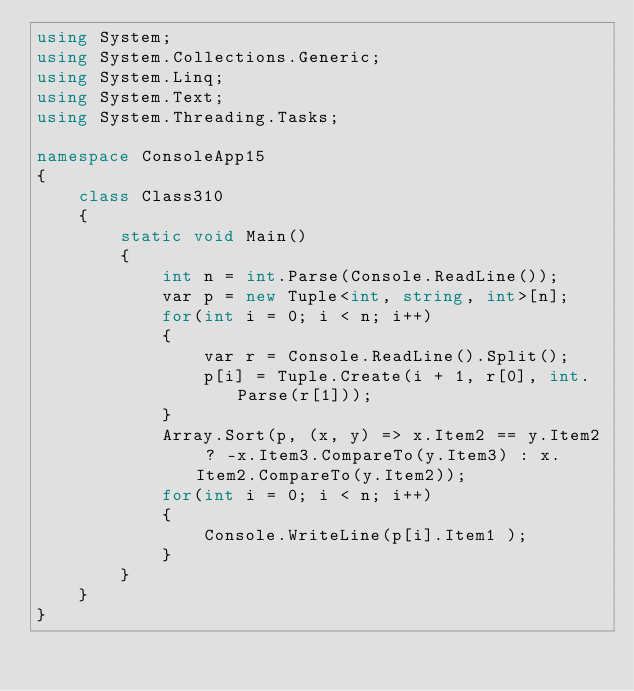<code> <loc_0><loc_0><loc_500><loc_500><_C#_>using System;
using System.Collections.Generic;
using System.Linq;
using System.Text;
using System.Threading.Tasks;

namespace ConsoleApp15
{
    class Class310
    {
        static void Main()
        {
            int n = int.Parse(Console.ReadLine());
            var p = new Tuple<int, string, int>[n];
            for(int i = 0; i < n; i++)
            {
                var r = Console.ReadLine().Split();
                p[i] = Tuple.Create(i + 1, r[0], int.Parse(r[1]));
            }
            Array.Sort(p, (x, y) => x.Item2 == y.Item2 ? -x.Item3.CompareTo(y.Item3) : x.Item2.CompareTo(y.Item2));
            for(int i = 0; i < n; i++)
            {
                Console.WriteLine(p[i].Item1 );
            }
        }
    }
}
</code> 